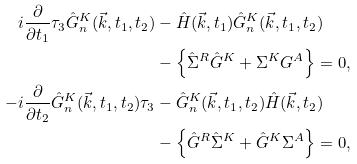Convert formula to latex. <formula><loc_0><loc_0><loc_500><loc_500>i \frac { \partial } { \partial t _ { 1 } } \tau _ { 3 } \hat { G } ^ { K } _ { n } ( \vec { k } , t _ { 1 } , t _ { 2 } ) & - \hat { H } ( \vec { k } , t _ { 1 } ) \hat { G } ^ { K } _ { n } ( \vec { k } , t _ { 1 } , t _ { 2 } ) \\ & - \left \{ \hat { \Sigma } ^ { R } \hat { G } ^ { K } + \Sigma ^ { K } G ^ { A } \right \} = 0 , \\ - i \frac { \partial } { \partial t _ { 2 } } \hat { G } ^ { K } _ { n } ( \vec { k } , t _ { 1 } , t _ { 2 } ) \tau _ { 3 } & - \hat { G } ^ { K } _ { n } ( \vec { k } , t _ { 1 } , t _ { 2 } ) \hat { H } ( \vec { k } , t _ { 2 } ) \\ & - \left \{ \hat { G } ^ { R } \hat { \Sigma } ^ { K } + \hat { G } ^ { K } \Sigma ^ { A } \right \} = 0 ,</formula> 